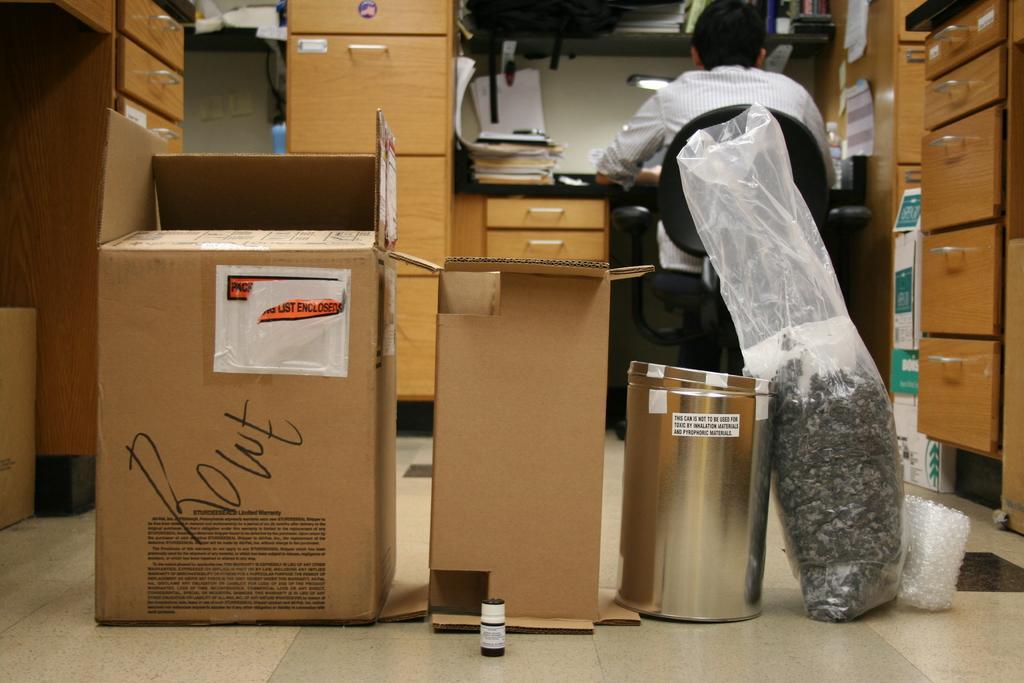Please provide a concise description of this image. In the picture we can see a floor with two cardboard boxes on it and beside it, we can see a thin and a polythene bag and besides to it, we can see some draws on the either sides and in the background also we can see some drawers and a table and near it we can see a man sitting on the chair and on the table we can see some files. 